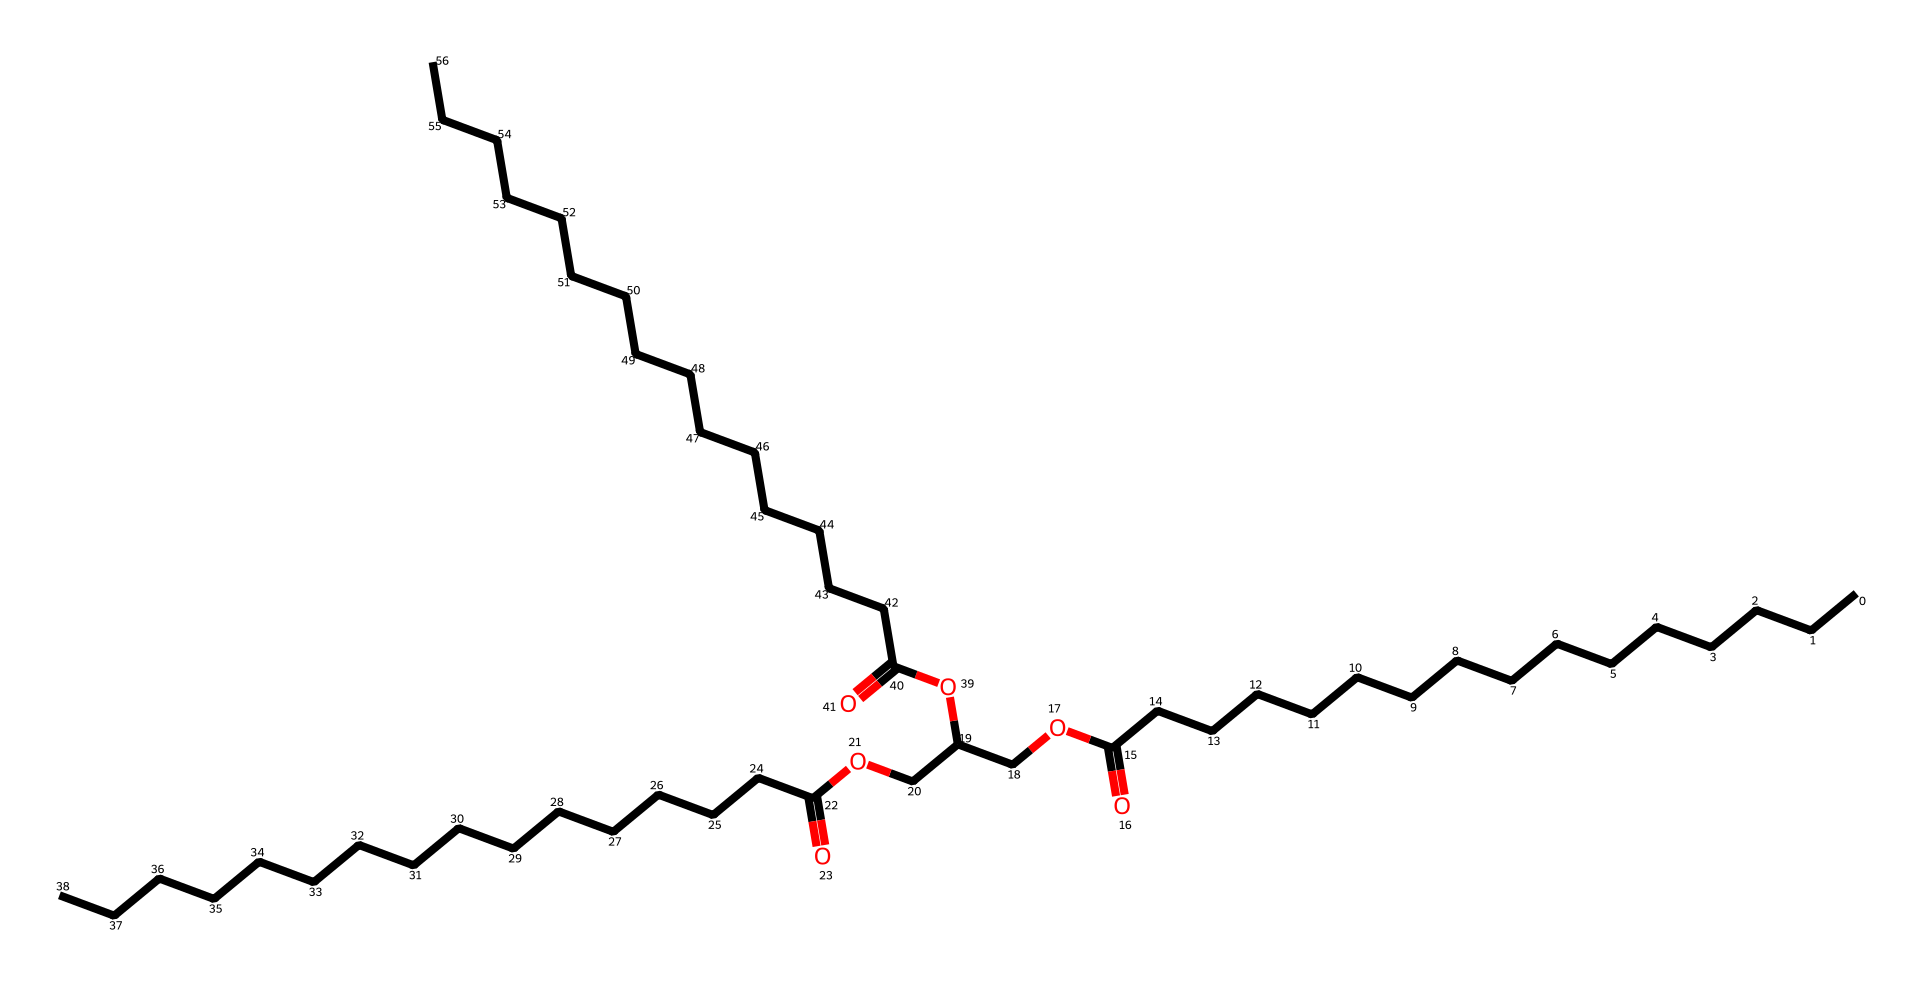What functional groups are present in this chemical? The chemical structure includes carboxyl groups (-COOH) and ester groups (-COO-). The presence of these functional groups can be identified by looking at the parts of the structure where carbon is double-bonded to oxygen and also single-bonded to oxygen.
Answer: carboxyl and ester How many carbon atoms are in this molecule? To find the number of carbon atoms, count the 'C' symbols present in the SMILES representation and consider the branching where carbon atoms are implied. There are 27 carbon atoms evident in the structure.
Answer: 27 What is the role of triglycerides in athletes' energy storage? Triglycerides function as a primary form of energy storage in the body, particularly beneficial during prolonged exercise, as they provide a concentrated source of calories. This is due to the high-energy fatty acid chains in their structure.
Answer: energy storage How many ester linkages are present in this triglyceride? The structure shows that there are three ester linkages connecting fatty acid chains to a glycerol backbone, which is consistent with the formation of triglycerides. This can be inferred from the three -COO- groups present in the structure connecting to the glycerol portion.
Answer: 3 What type of lipid does this chemical structure represent? Given the presence of three fatty acid chains connected to a glycerol molecule via ester linkages, this chemical is classified as a triglyceride, which is a common type of fat or lipid found in the body.
Answer: triglyceride 